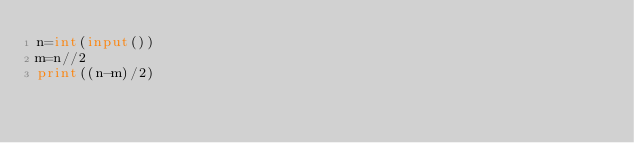Convert code to text. <code><loc_0><loc_0><loc_500><loc_500><_Python_>n=int(input())
m=n//2
print((n-m)/2)</code> 